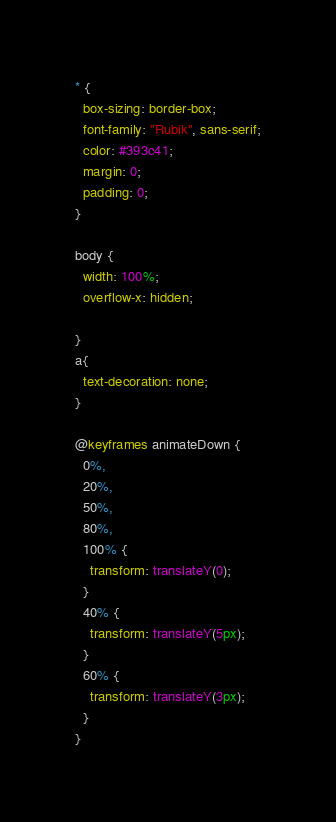Convert code to text. <code><loc_0><loc_0><loc_500><loc_500><_CSS_>* {
  box-sizing: border-box;
  font-family: "Rubik", sans-serif;
  color: #393c41;
  margin: 0;
  padding: 0;
}

body {
  width: 100%;
  overflow-x: hidden; 
  
}
a{
  text-decoration: none;
}

@keyframes animateDown {
  0%,
  20%,
  50%,
  80%,
  100% {
    transform: translateY(0);
  }
  40% {
    transform: translateY(5px);
  }
  60% {
    transform: translateY(3px);
  }
}
</code> 